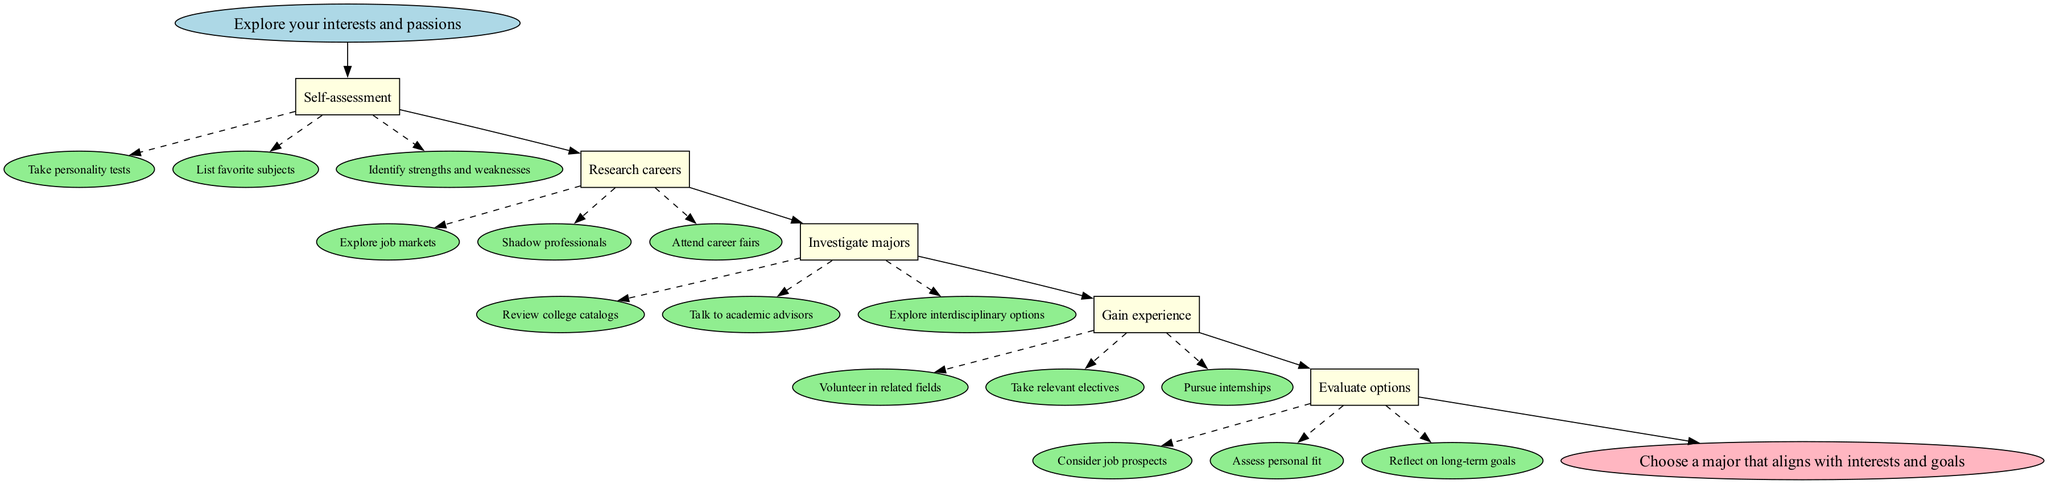What is the first step in the flow chart? The first step in the flow chart is labeled "Self-assessment" and follows "Explore your interests and passions." Since it is the first node after the starting point, it is straightforward to identify.
Answer: Self-assessment How many major steps are there in the process? The flow chart displays five major steps, as each step node represents a specific phase in the process of choosing a college major. Counting each step reveals there are five.
Answer: 5 What action should you take under "Research careers"? Under "Research careers," one of the actions listed is to "Explore job markets." This action is explicitly mentioned in the relevant section of the flow chart.
Answer: Explore job markets What is the last step before choosing a major? The last step before choosing a major is labeled "Evaluate options," which comes immediately before the end node that indicates selecting a major. Thus, it is the penultimate phase in the flow chart.
Answer: Evaluate options Which step includes volunteering as an action? The step that includes volunteering as an action is "Gain experience." This step has multiple actions listed, and "Volunteer in related fields" is one of them.
Answer: Gain experience How many actions are listed under "Investigate majors"? There are three actions listed under the "Investigate majors" step, including reviewing college catalogs, talking to academic advisors, and exploring interdisciplinary options, which can be counted directly.
Answer: 3 What is the relationship between "Gain experience" and "Evaluate options"? The relationship is that "Gain experience" is directly connected to "Evaluate options" through an edge, meaning that after gaining experience, the next logical step is to evaluate the options available for a major. This shows the flow of the process.
Answer: Sequential Connection What type of node is used for each action in the chart? Each action in the flow chart is a type of node shaped like an ellipse, as indicated in the diagram's structure, which differentiates these action items from the step nodes.
Answer: Ellipse 